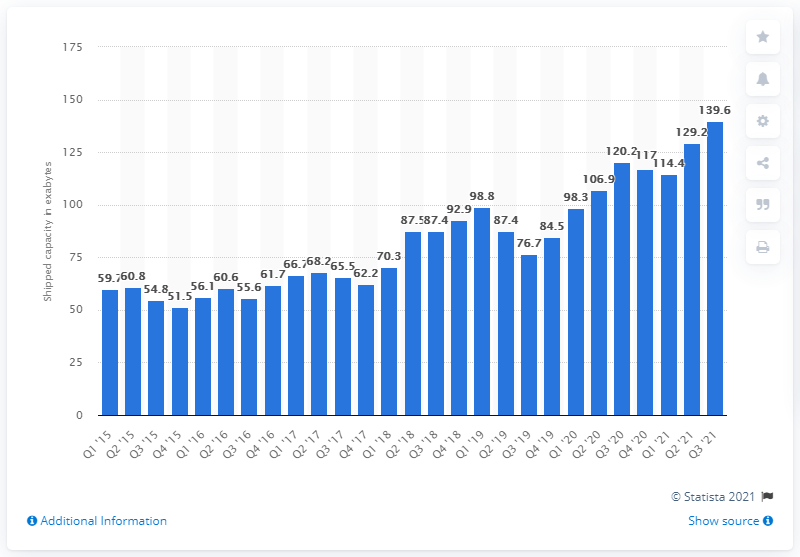Indicate a few pertinent items in this graphic. Seagate shipped a total of 139.6 exabytes of storage in the third quarter of 2021. 